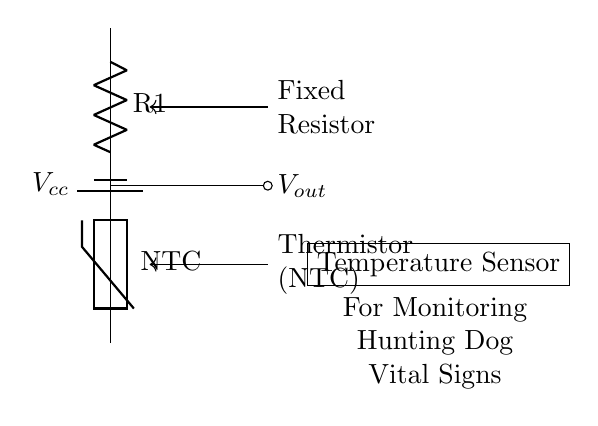What type of thermistor is used in this circuit? The circuit shows a thermistor labeled as NTC, indicating it is a Negative Temperature Coefficient thermistor. An NTC thermistor's resistance decreases with an increase in temperature.
Answer: NTC What is the output voltage denoted as in this circuit? The output voltage is indicated by the label Vout, which is the voltage across the thermistor and is taken from the voltage divider formed by R1 and the thermistor.
Answer: Vout What is the purpose of the fixed resistor R1 in this configuration? The fixed resistor R1 acts as a voltage divider in conjunction with the thermistor, allowing the circuit to produce a variable output voltage that changes with temperature. This is crucial for monitoring the temperature.
Answer: Voltage divider How does increasing temperature affect the output voltage Vout? As temperature increases, the resistance of the NTC thermistor decreases, which leads to a higher output voltage Vout. This is because the voltage across the thermistor is inversely related to its resistance in the divider configuration.
Answer: Increases What is the relationship between the power supply and the thermistor in this circuit? The power supply voltage Vcc provides the necessary input voltage for the voltage divider, influencing both the voltage across the thermistor and the output voltage Vout. The divider’s output is directly dependent on the supply voltage.
Answer: Power supply voltage What will happen if the thermistor is replaced with a PTC thermistor? If a PTC (Positive Temperature Coefficient) thermistor is used instead, the circuit behavior will change; as the temperature increases, the output voltage Vout will decrease, opposing the behavior of the NTC thermistor. Thus, the temperature response would be inverted.
Answer: Inverted response 